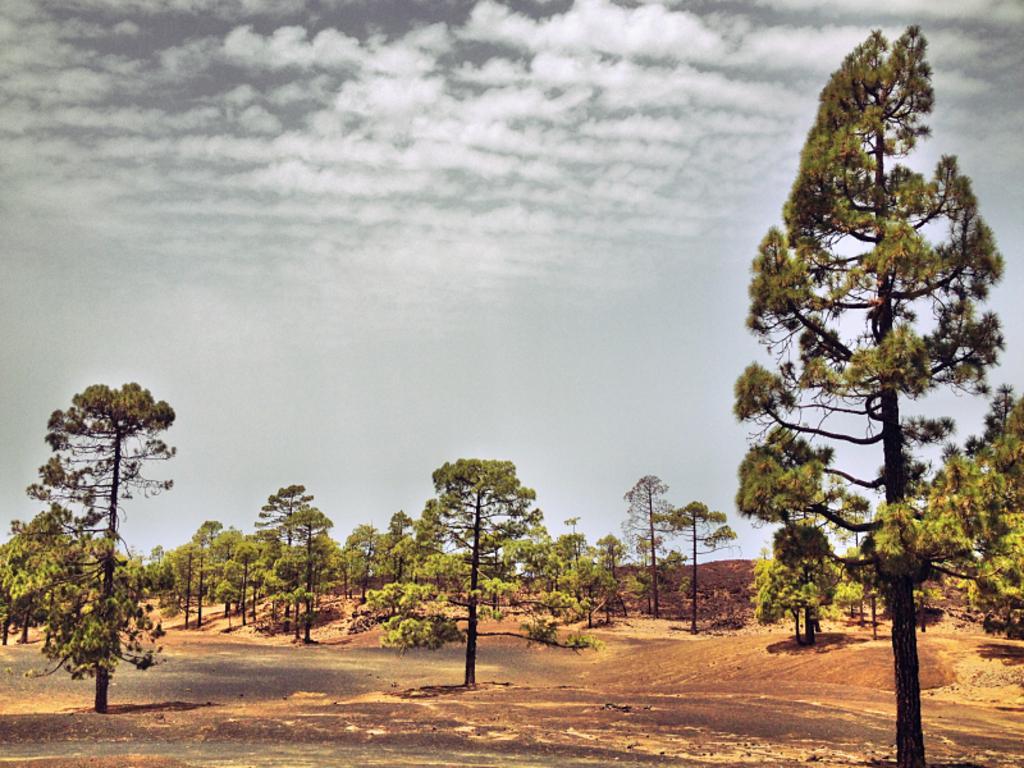Could you give a brief overview of what you see in this image? As we can see in the image there are trees, sky and clouds. 